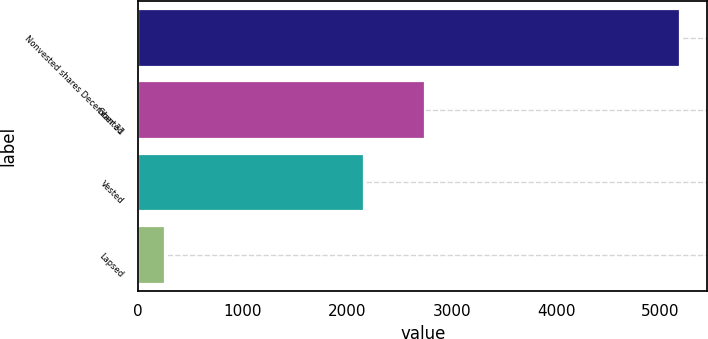Convert chart to OTSL. <chart><loc_0><loc_0><loc_500><loc_500><bar_chart><fcel>Nonvested shares December 31<fcel>Granted<fcel>Vested<fcel>Lapsed<nl><fcel>5189.3<fcel>2749<fcel>2164<fcel>251<nl></chart> 